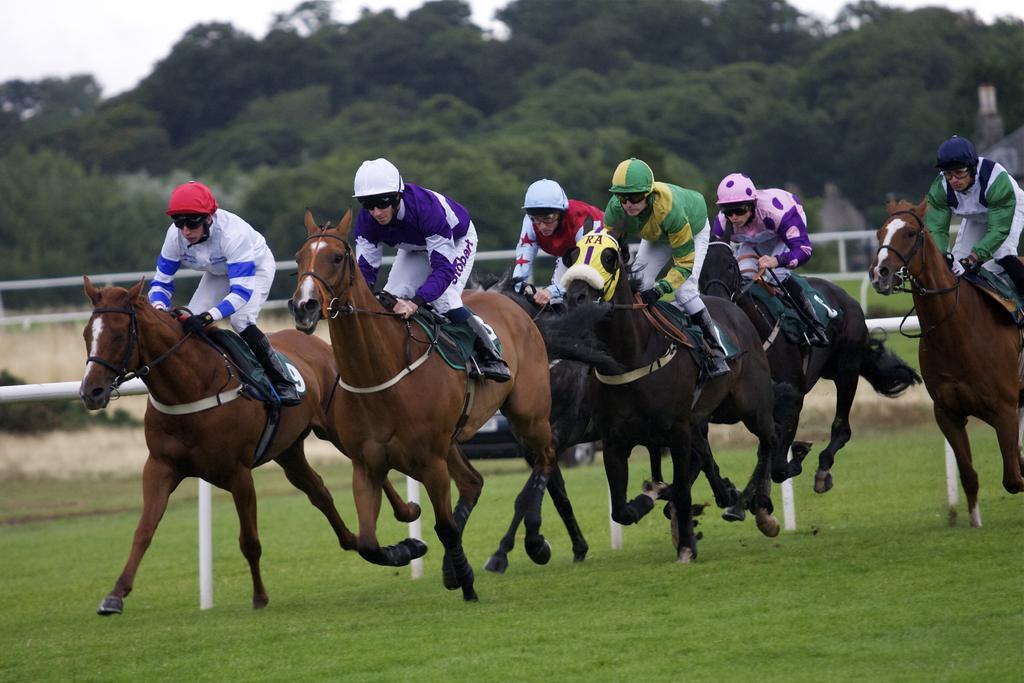Can you describe this image briefly? In this picture we can see some people riding horses, at the bottom there is grass, these people wore helmets, in the background there are some trees. 